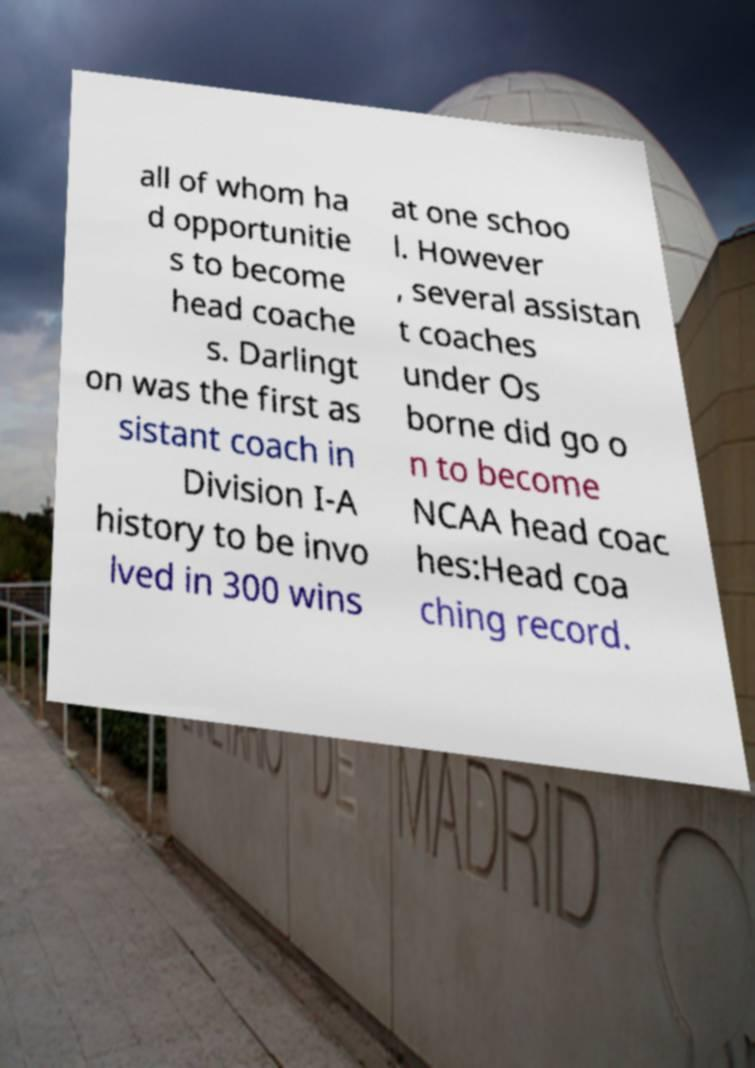Can you accurately transcribe the text from the provided image for me? all of whom ha d opportunitie s to become head coache s. Darlingt on was the first as sistant coach in Division I-A history to be invo lved in 300 wins at one schoo l. However , several assistan t coaches under Os borne did go o n to become NCAA head coac hes:Head coa ching record. 